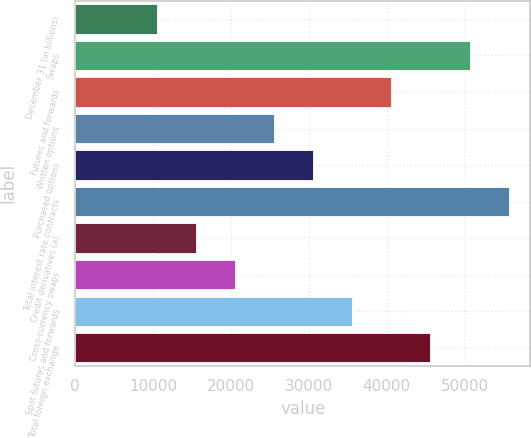<chart> <loc_0><loc_0><loc_500><loc_500><bar_chart><fcel>December 31 (in billions)<fcel>Swaps<fcel>Futures and forwards<fcel>Written options<fcel>Purchased options<fcel>Total interest rate contracts<fcel>Credit derivatives (a)<fcel>Cross-currency swaps<fcel>Spot futures and forwards<fcel>Total foreign exchange<nl><fcel>10459<fcel>50659<fcel>40609<fcel>25534<fcel>30559<fcel>55684<fcel>15484<fcel>20509<fcel>35584<fcel>45634<nl></chart> 